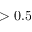Convert formula to latex. <formula><loc_0><loc_0><loc_500><loc_500>> 0 . 5</formula> 